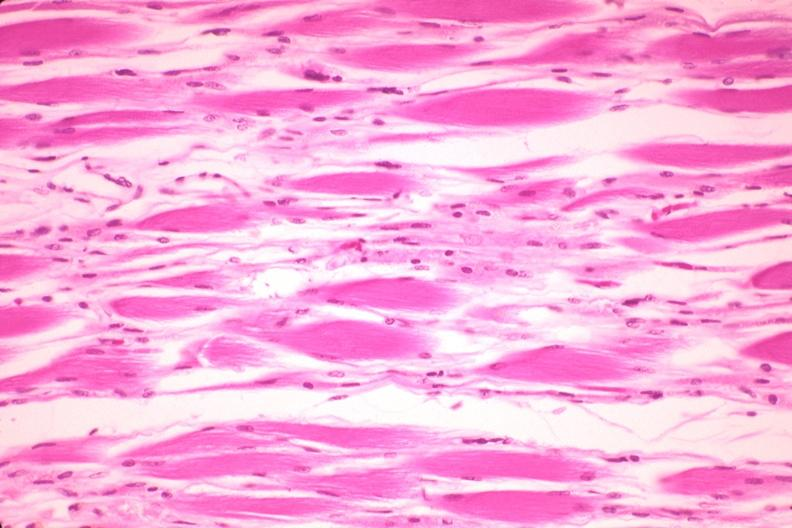what is present?
Answer the question using a single word or phrase. Muscle 